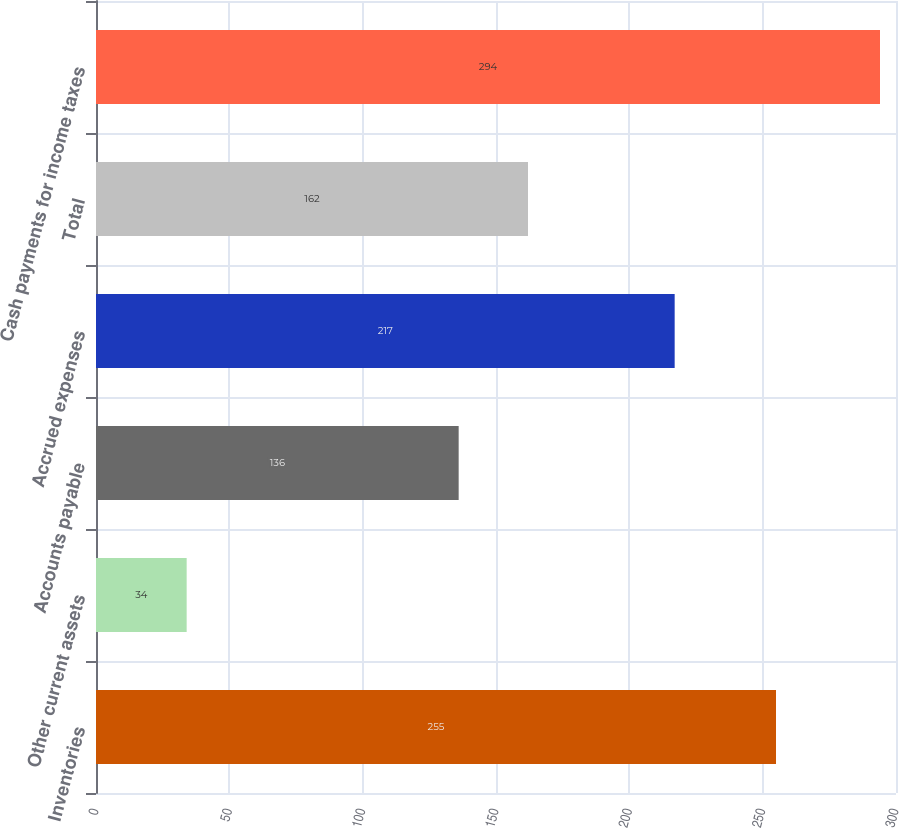<chart> <loc_0><loc_0><loc_500><loc_500><bar_chart><fcel>Inventories<fcel>Other current assets<fcel>Accounts payable<fcel>Accrued expenses<fcel>Total<fcel>Cash payments for income taxes<nl><fcel>255<fcel>34<fcel>136<fcel>217<fcel>162<fcel>294<nl></chart> 